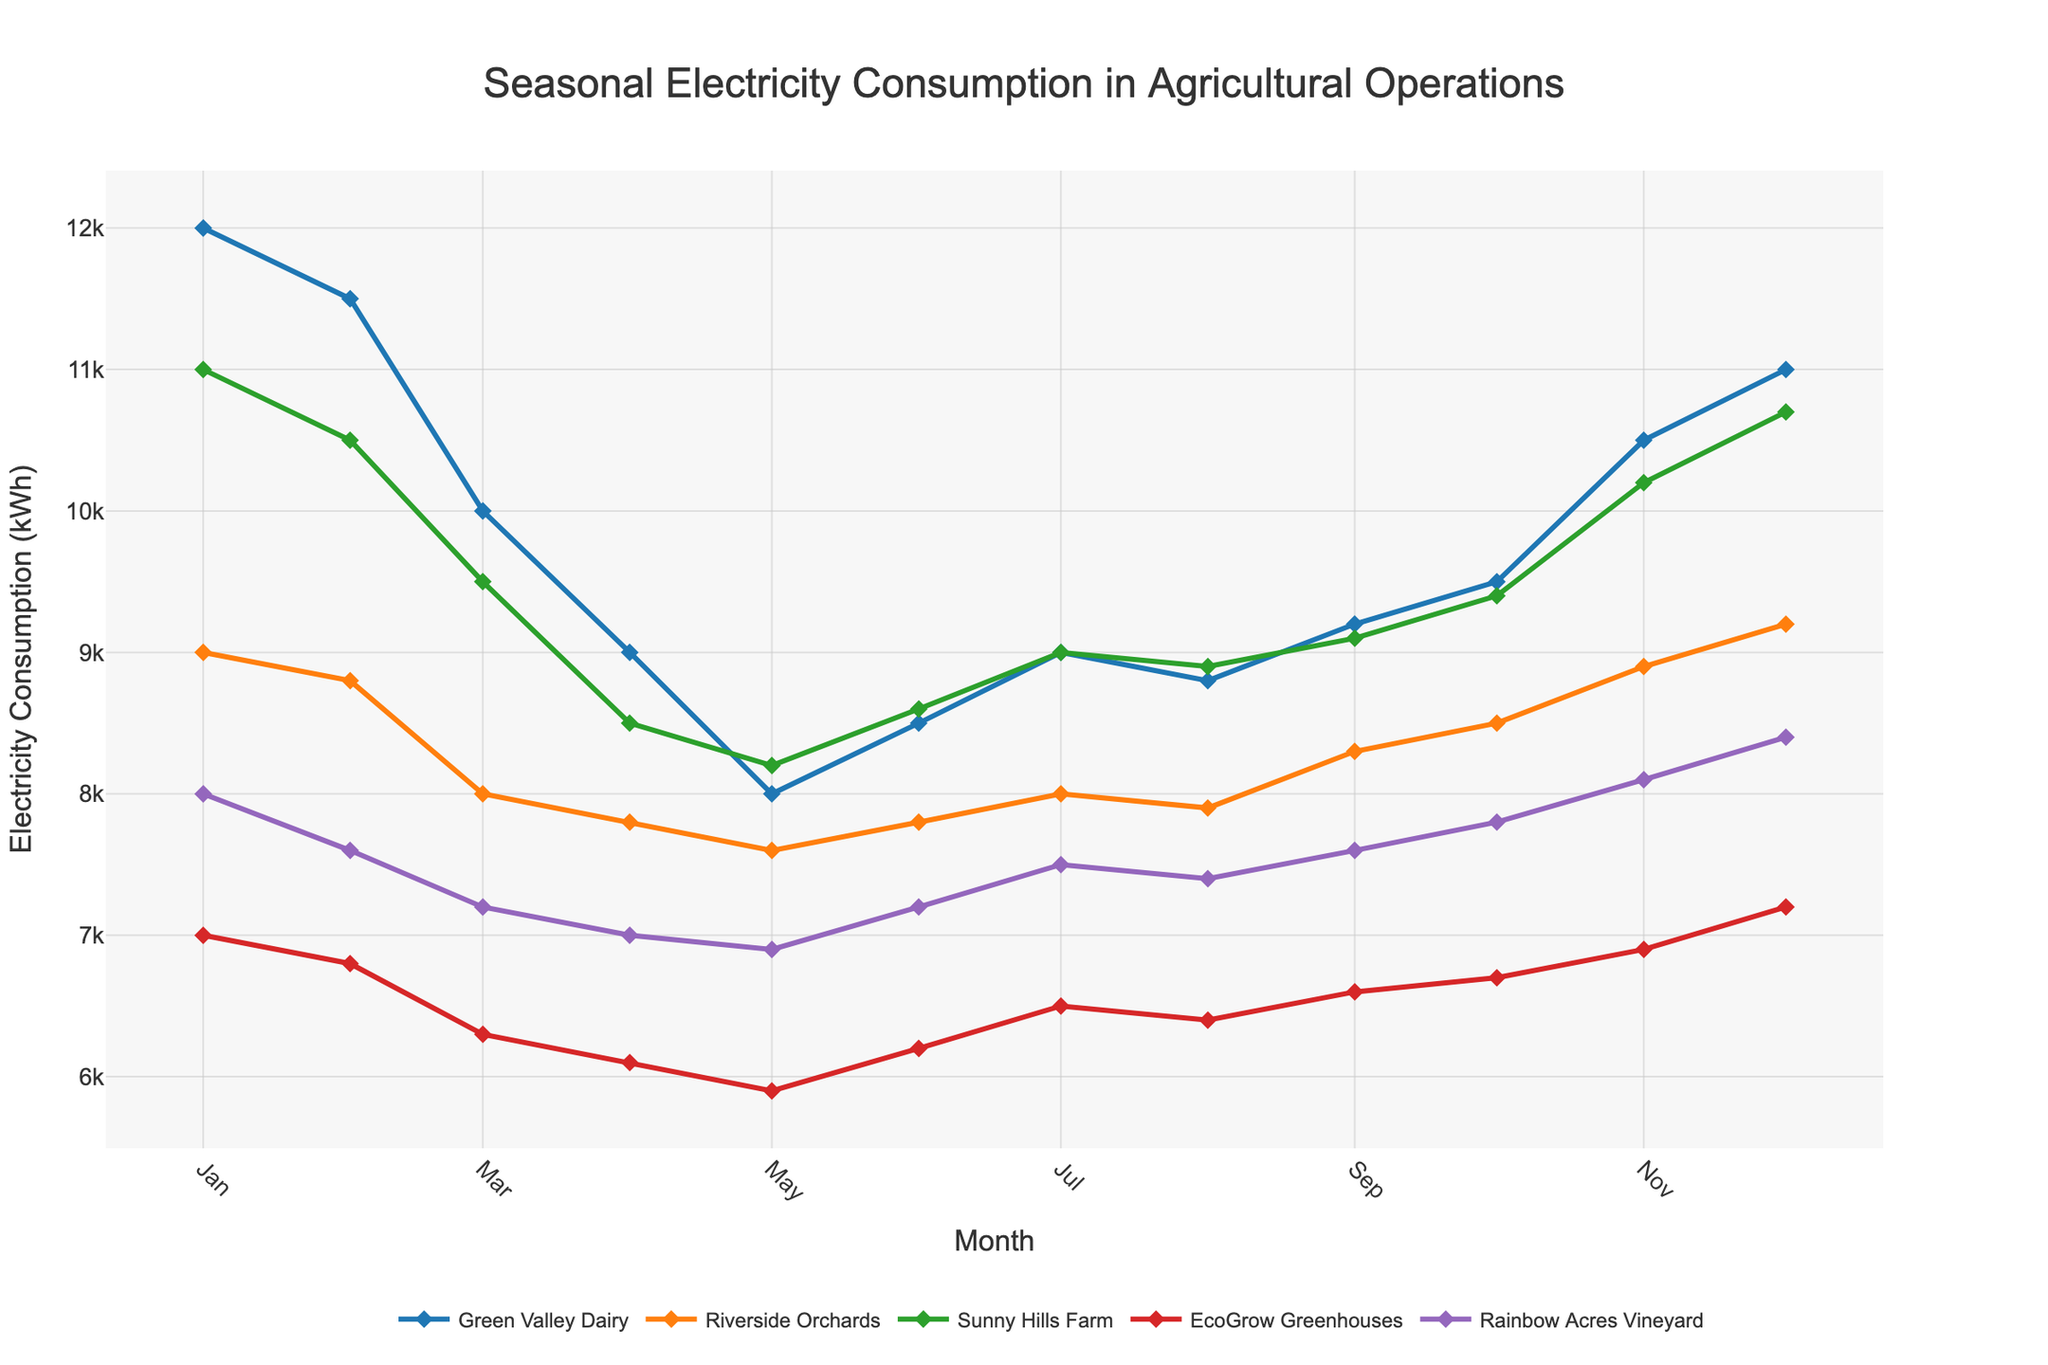How many agricultural operations are represented in the plot? By looking at the legend of the plot, we can count the number of different labels present. These labels represent the different agricultural operations included in the dataset.
Answer: 5 Which agricultural operation had the highest electricity consumption in January? From the plot, identify the month of January on the x-axis and look at the corresponding y-values for each agricultural operation. The data point with the highest y-value represents the highest consumption.
Answer: Green Valley Dairy During which month did Riverside Orchards consume the least electricity? Identify the line representing Riverside Orchards from the legend. Follow this line and identify the lowest data point on the y-axis, then trace it back to the corresponding month on the x-axis.
Answer: May What is the general trend of EcoGrow Greenhouses' electricity consumption throughout the year? Identify the line for EcoGrow Greenhouses from the legend and observe its pattern from January to December. Describe whether it generally increases, decreases, or fluctuates.
Answer: Fluctuates Which agricultural operation showed the most significant increase in electricity consumption from April to November? Calculate the difference in electricity consumption values between April and November for each agricultural operation and identify which one has the largest increase.
Answer: Green Valley Dairy What is the average electricity consumption for Sunny Hills Farm over the year? Sum up the electricity consumption values for Sunny Hills Farm across all months and then divide by the number of months (12).
Answer: 9333.33 kWh Are there any months where all agricultural operations' electricity consumptions were either all increasing or all decreasing? Look at the lines for each agricultural operation and identify if there are any months where every line either rises or falls compared to the previous month.
Answer: No Which agricultural operation had the most stable electricity consumption pattern throughout the year? Examine the lines representing each agricultural operation in terms of variability through the months. The operation with the least fluctuation will have the most stable pattern.
Answer: Riverside Orchards 